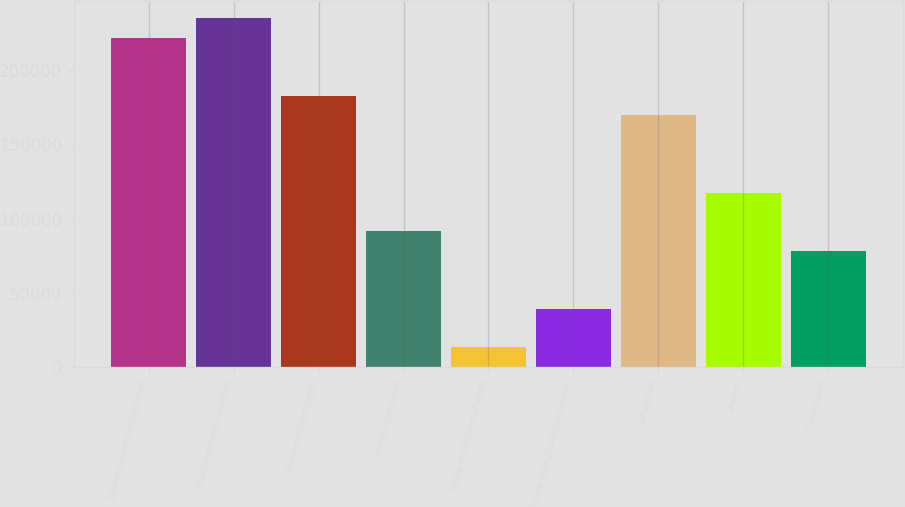Convert chart to OTSL. <chart><loc_0><loc_0><loc_500><loc_500><bar_chart><fcel>Taxable investment securities<fcel>Total investment securities<fcel>Residential mortgages<fcel>Home equity loans<fcel>Home equity lines of credit<fcel>Home equity loans serviced by<fcel>Automobile<fcel>Student<fcel>Credit cards<nl><fcel>221812<fcel>234852<fcel>182694<fcel>91417.5<fcel>13180.5<fcel>39259.5<fcel>169654<fcel>117496<fcel>78378<nl></chart> 